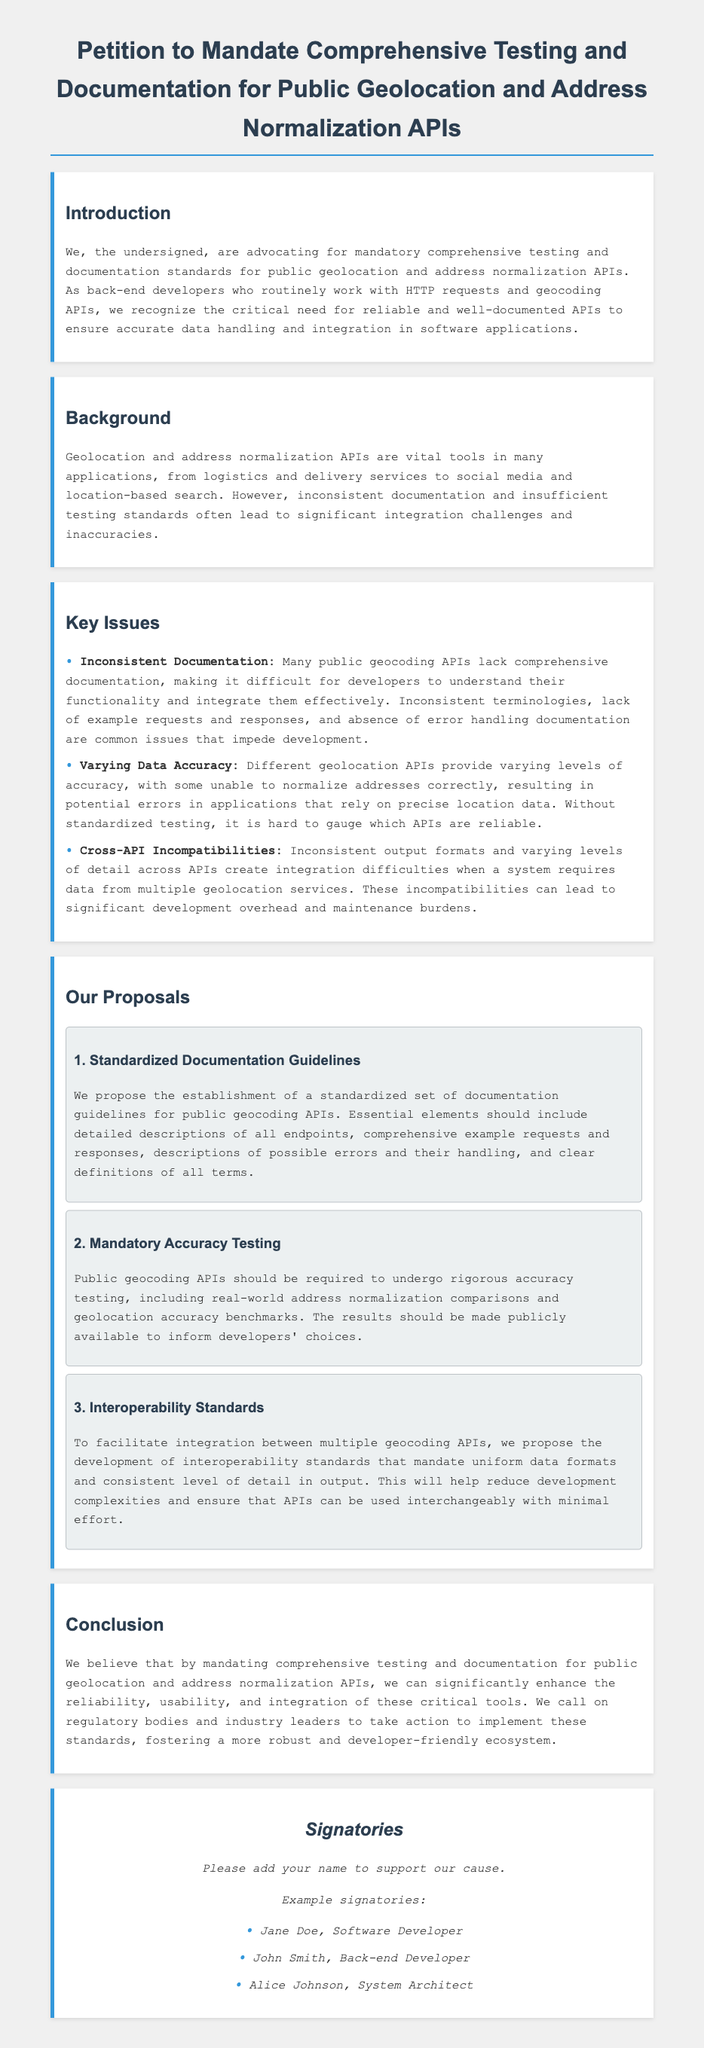What is the title of the petition? The title of the petition is presented at the top of the document.
Answer: Petition to Mandate Comprehensive Testing and Documentation for Public Geolocation and Address Normalization APIs Who is the target audience for this petition? The petition is directed at regulatory bodies and industry leaders, as stated in the conclusion.
Answer: Regulatory bodies and industry leaders What are the three main proposals outlined in the petition? The proposals are listed under "Our Proposals" section; they include Standardized Documentation Guidelines, Mandatory Accuracy Testing, and Interoperability Standards.
Answer: Standardized Documentation Guidelines, Mandatory Accuracy Testing, Interoperability Standards How many example signatories are provided in the document? The document includes a list of three example signatories.
Answer: Three What is one key issue mentioned regarding data accuracy? The problem highlighted pertains to the varying levels of accuracy provided by different geolocation APIs, which directly affects application reliability.
Answer: Varying Data Accuracy What does the proposal for Mandatory Accuracy Testing suggest? This proposal suggests that public geocoding APIs undergo rigorous accuracy testing, with results made publicly available.
Answer: Rigorous accuracy testing What type of document is this? This document is a petition advocating for certain standards in geocoding APIs.
Answer: Petition What is the main purpose of the petition? The main purpose is to advocate for mandatory testing and documentation standards for geolocation APIs.
Answer: Advocate for mandatory testing and documentation standards 